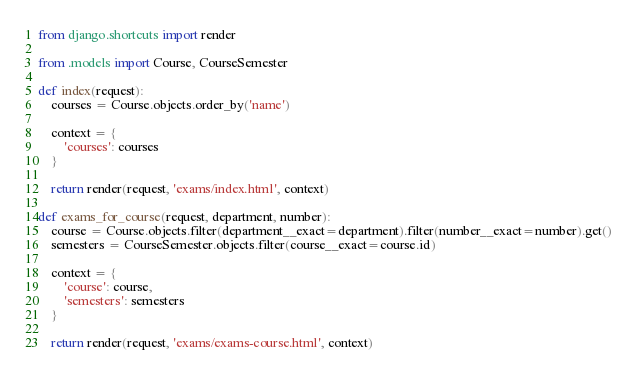Convert code to text. <code><loc_0><loc_0><loc_500><loc_500><_Python_>from django.shortcuts import render

from .models import Course, CourseSemester

def index(request):
	courses = Course.objects.order_by('name')

	context = {
		'courses': courses
	}

	return render(request, 'exams/index.html', context)

def exams_for_course(request, department, number):
	course = Course.objects.filter(department__exact=department).filter(number__exact=number).get()
	semesters = CourseSemester.objects.filter(course__exact=course.id)

	context = {
		'course': course,
		'semesters': semesters
	}

	return render(request, 'exams/exams-course.html', context)</code> 